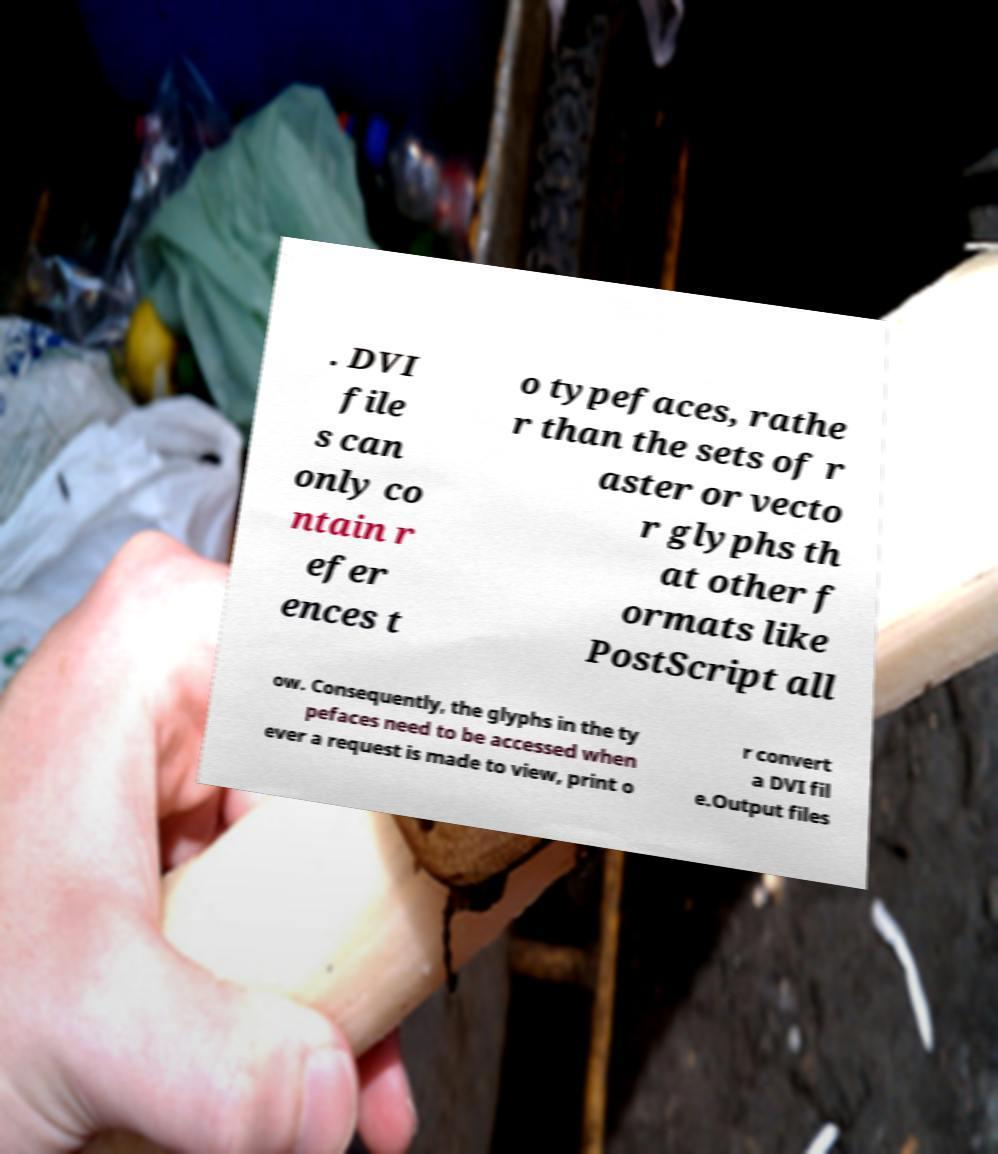Can you accurately transcribe the text from the provided image for me? . DVI file s can only co ntain r efer ences t o typefaces, rathe r than the sets of r aster or vecto r glyphs th at other f ormats like PostScript all ow. Consequently, the glyphs in the ty pefaces need to be accessed when ever a request is made to view, print o r convert a DVI fil e.Output files 